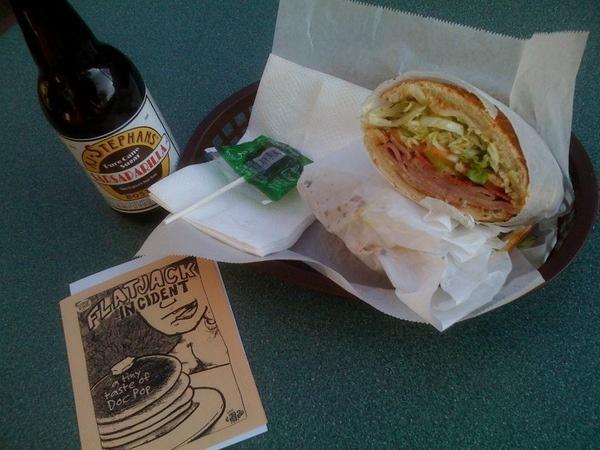This beverage tastes similar to what other beverage?
Choose the right answer from the provided options to respond to the question.
Options: Sprite, ginger ale, sorrel drink, root beer. Root beer. 